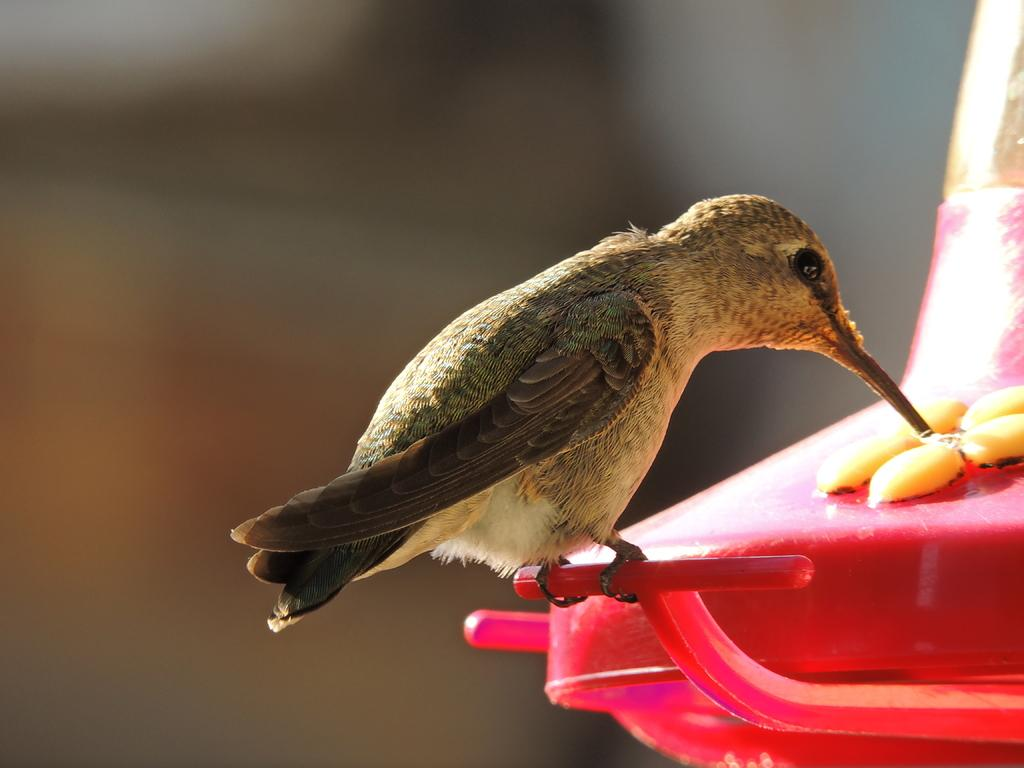What type of animal can be seen in the image? There is a bird in the image. What is the bird doing in the image? The bird is standing on an object and appears to be eating yellow color objects. Can you describe the background of the image? The background of the image is blurry. What type of ship can be seen in the image? There is no ship present in the image; it features a bird standing on an object and eating yellow color objects. What kind of pest is causing trouble for the bird in the image? There is no pest present in the image; the bird is eating yellow color objects while standing on an object. 